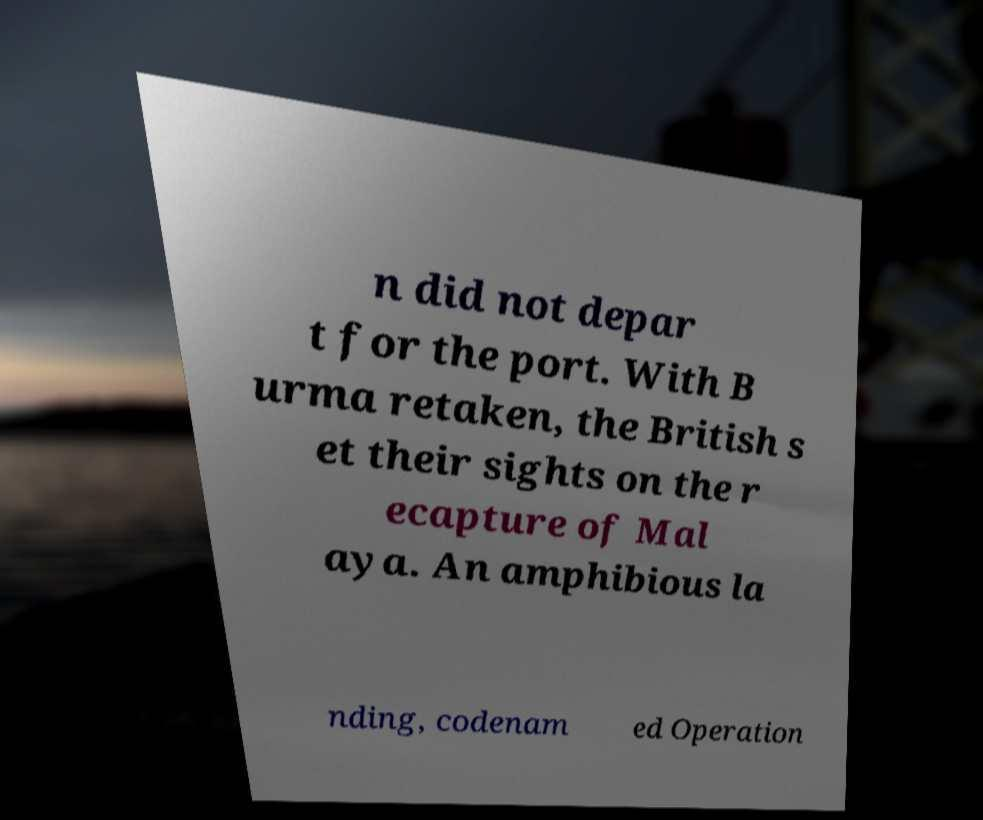There's text embedded in this image that I need extracted. Can you transcribe it verbatim? n did not depar t for the port. With B urma retaken, the British s et their sights on the r ecapture of Mal aya. An amphibious la nding, codenam ed Operation 